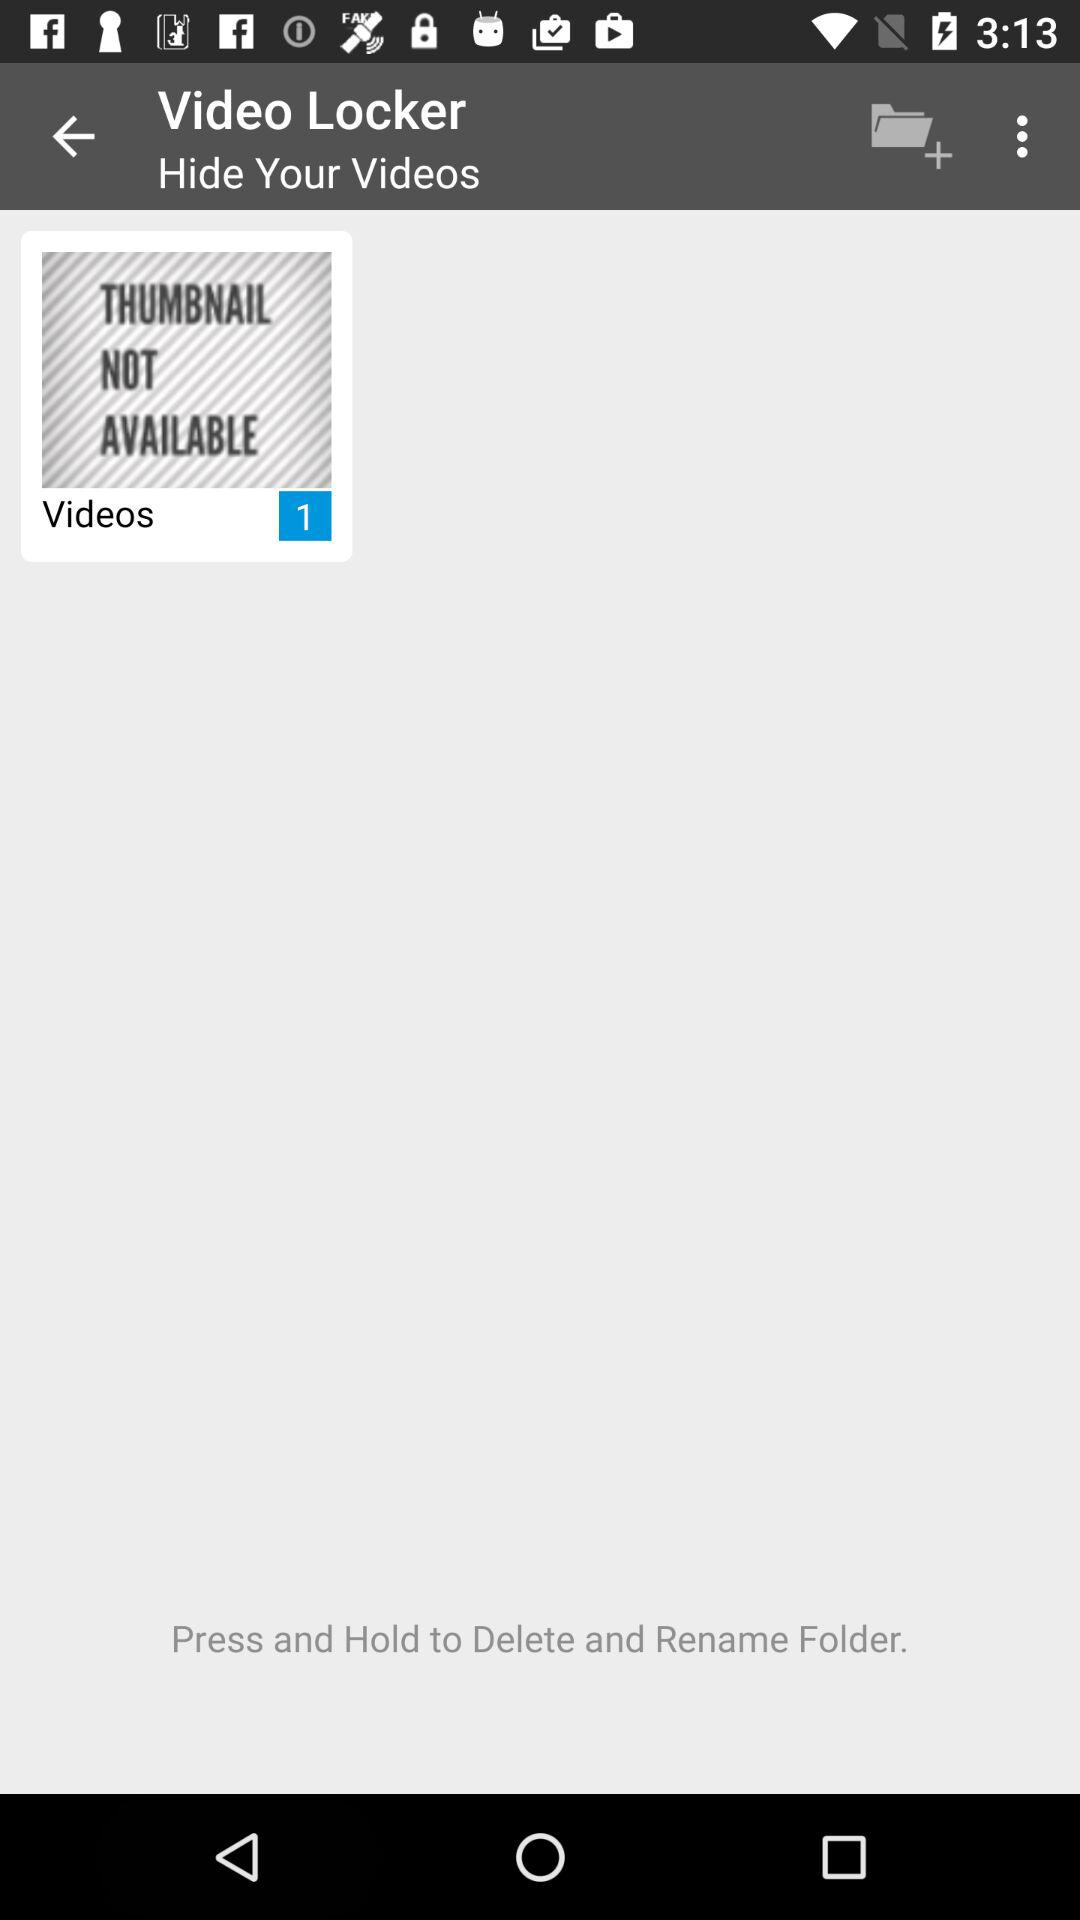How many videos are in the video locker?
Answer the question using a single word or phrase. 1 